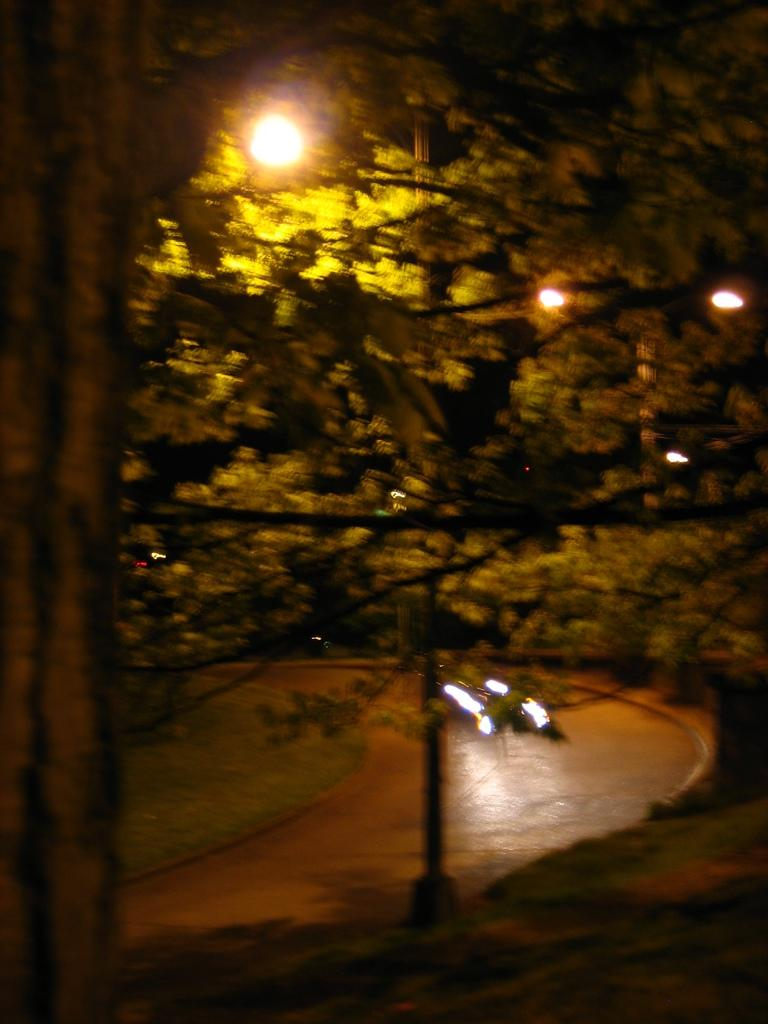What is happening on the road in the image? There are vehicles on the road in the image. What can be seen in the distance behind the vehicles? There are trees and lights visible in the background of the image. What type of square is being used to clean the chain in the image? There is no square or chain present in the image. 